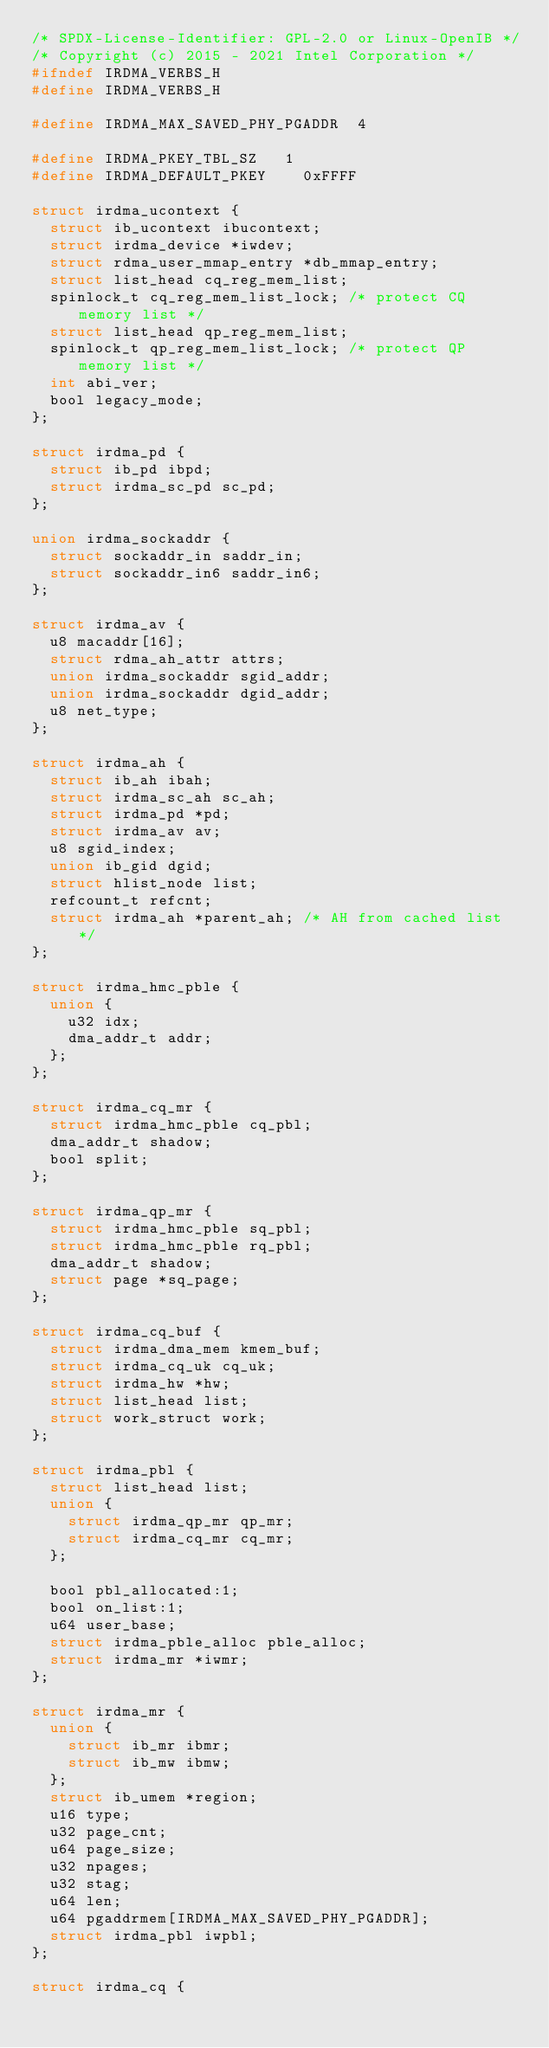<code> <loc_0><loc_0><loc_500><loc_500><_C_>/* SPDX-License-Identifier: GPL-2.0 or Linux-OpenIB */
/* Copyright (c) 2015 - 2021 Intel Corporation */
#ifndef IRDMA_VERBS_H
#define IRDMA_VERBS_H

#define IRDMA_MAX_SAVED_PHY_PGADDR	4

#define IRDMA_PKEY_TBL_SZ		1
#define IRDMA_DEFAULT_PKEY		0xFFFF

struct irdma_ucontext {
	struct ib_ucontext ibucontext;
	struct irdma_device *iwdev;
	struct rdma_user_mmap_entry *db_mmap_entry;
	struct list_head cq_reg_mem_list;
	spinlock_t cq_reg_mem_list_lock; /* protect CQ memory list */
	struct list_head qp_reg_mem_list;
	spinlock_t qp_reg_mem_list_lock; /* protect QP memory list */
	int abi_ver;
	bool legacy_mode;
};

struct irdma_pd {
	struct ib_pd ibpd;
	struct irdma_sc_pd sc_pd;
};

union irdma_sockaddr {
	struct sockaddr_in saddr_in;
	struct sockaddr_in6 saddr_in6;
};

struct irdma_av {
	u8 macaddr[16];
	struct rdma_ah_attr attrs;
	union irdma_sockaddr sgid_addr;
	union irdma_sockaddr dgid_addr;
	u8 net_type;
};

struct irdma_ah {
	struct ib_ah ibah;
	struct irdma_sc_ah sc_ah;
	struct irdma_pd *pd;
	struct irdma_av av;
	u8 sgid_index;
	union ib_gid dgid;
	struct hlist_node list;
	refcount_t refcnt;
	struct irdma_ah *parent_ah; /* AH from cached list */
};

struct irdma_hmc_pble {
	union {
		u32 idx;
		dma_addr_t addr;
	};
};

struct irdma_cq_mr {
	struct irdma_hmc_pble cq_pbl;
	dma_addr_t shadow;
	bool split;
};

struct irdma_qp_mr {
	struct irdma_hmc_pble sq_pbl;
	struct irdma_hmc_pble rq_pbl;
	dma_addr_t shadow;
	struct page *sq_page;
};

struct irdma_cq_buf {
	struct irdma_dma_mem kmem_buf;
	struct irdma_cq_uk cq_uk;
	struct irdma_hw *hw;
	struct list_head list;
	struct work_struct work;
};

struct irdma_pbl {
	struct list_head list;
	union {
		struct irdma_qp_mr qp_mr;
		struct irdma_cq_mr cq_mr;
	};

	bool pbl_allocated:1;
	bool on_list:1;
	u64 user_base;
	struct irdma_pble_alloc pble_alloc;
	struct irdma_mr *iwmr;
};

struct irdma_mr {
	union {
		struct ib_mr ibmr;
		struct ib_mw ibmw;
	};
	struct ib_umem *region;
	u16 type;
	u32 page_cnt;
	u64 page_size;
	u32 npages;
	u32 stag;
	u64 len;
	u64 pgaddrmem[IRDMA_MAX_SAVED_PHY_PGADDR];
	struct irdma_pbl iwpbl;
};

struct irdma_cq {</code> 